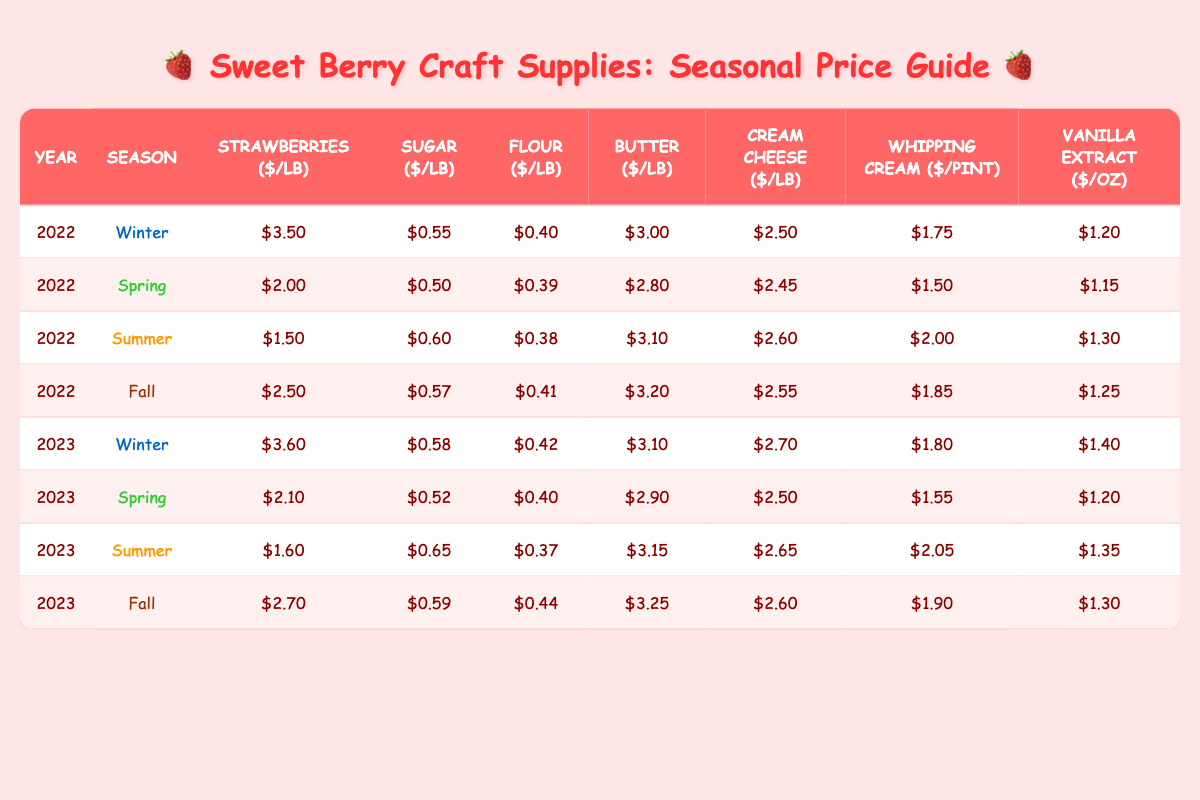What was the cost of strawberries per pound in summer 2022? In the table, find the row for the year 2022 and the season "Summer." The value for strawberries per pound in that row is $1.50.
Answer: $1.50 What was the highest cost of sugar per pound across all seasons in 2023? Review each season for the year 2023. The values for sugar per pound are: Winter $0.58, Spring $0.52, Summer $0.65, Fall $0.59. The highest value is $0.65 in Summer.
Answer: $0.65 What is the cost of cream cheese in fall 2022? Locate the year 2022 and the season "Fall" in the table. The cost of cream cheese per pound in that row is $2.55.
Answer: $2.55 Which season had the lowest cost of butter in 2022? In 2022, the costs of butter by season were Winter $3.00, Spring $2.80, Summer $3.10, and Fall $3.20. The lowest price is $2.80 in Spring.
Answer: Spring What is the average cost of flour per pound in 2023? The values for flour per pound in 2023 are: Winter $0.42, Spring $0.40, Summer $0.37, Fall $0.44. Adding these gives $0.42 + $0.40 + $0.37 + $0.44 = $1.63. Dividing by 4 seasons gives an average of $1.63 / 4 = $0.4075, approximately $0.41.
Answer: $0.41 Did the cost of strawberries increase from Winter 2022 to Winter 2023? Compare the cost of strawberries in Winter 2022 ($3.50) and Winter 2023 ($3.60). Since $3.60 is greater than $3.50, the cost increased.
Answer: Yes Which ingredient had the highest cost in Summer 2023, and what was that cost? Review the Summer 2023 row. The values are: strawberries $1.60, sugar $0.65, flour $0.37, butter $3.15, cream cheese $2.65, whipping cream $2.05, vanilla extract $1.35. The highest is $3.15 for butter.
Answer: Butter; $3.15 How much more did cream cheese cost in Winter 2023 compared to Winter 2022? The cost of cream cheese in Winter 2022 is $2.50 and in Winter 2023 is $2.70. Subtracting $2.50 from $2.70 gives $0.20.
Answer: $0.20 What was the total cost of all ingredient components for Spring 2023? For Spring 2023, the costs are strawberries $2.10, sugar $0.52, flour $0.40, butter $2.90, cream cheese $2.50, whipping cream $1.55, vanilla extract $1.20. Adding these gives $2.10 + $0.52 + $0.40 + $2.90 + $2.50 + $1.55 + $1.20 = $12.17.
Answer: $12.17 Was the cost of vanilla extract higher in Fall 2022 than in Spring 2023? The cost of vanilla in Fall 2022 is $1.25 and in Spring 2023 is $1.20. Since $1.25 is greater than $1.20, the statement is true.
Answer: Yes 